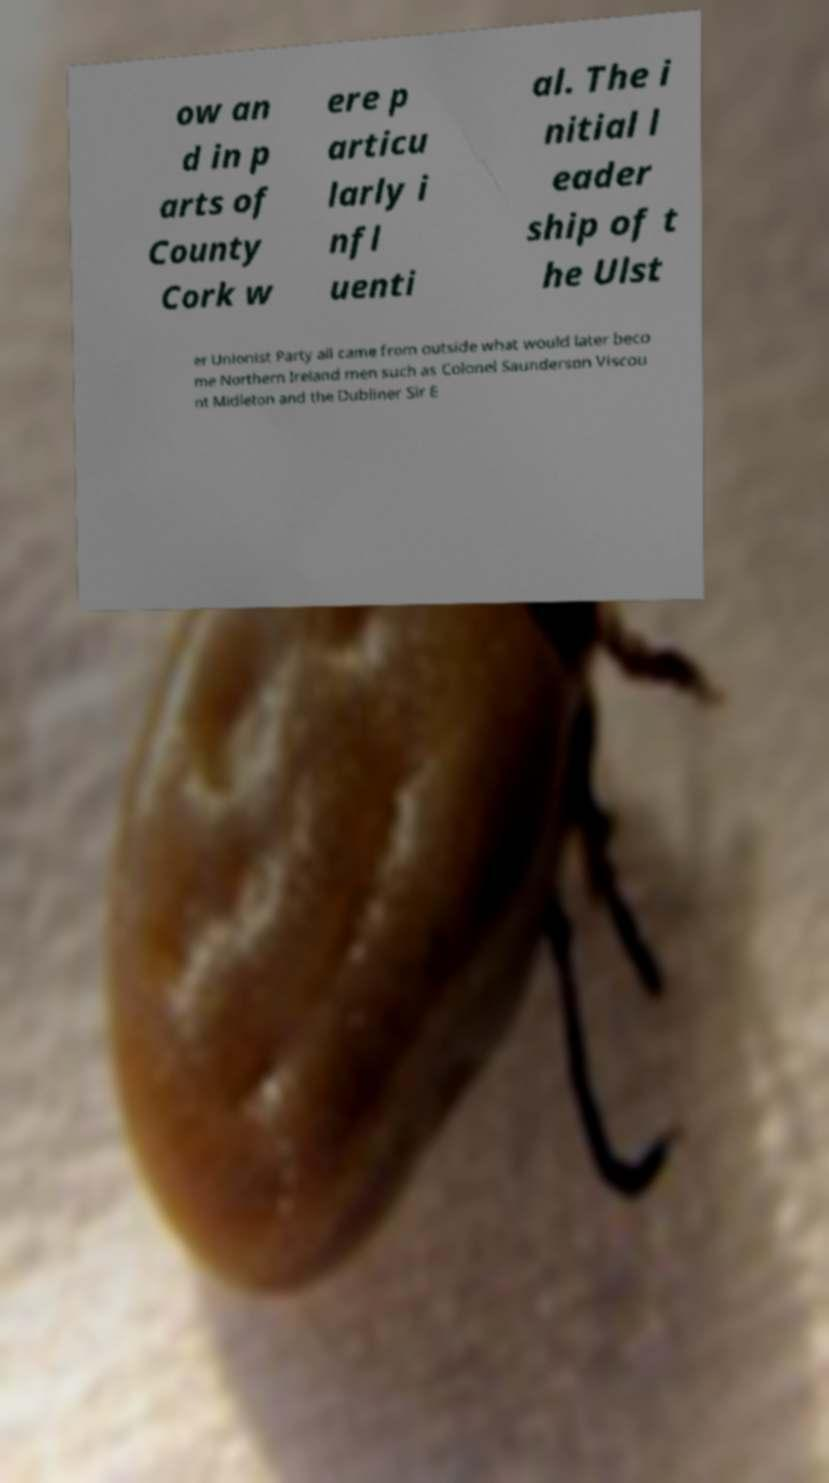There's text embedded in this image that I need extracted. Can you transcribe it verbatim? ow an d in p arts of County Cork w ere p articu larly i nfl uenti al. The i nitial l eader ship of t he Ulst er Unionist Party all came from outside what would later beco me Northern Ireland men such as Colonel Saunderson Viscou nt Midleton and the Dubliner Sir E 